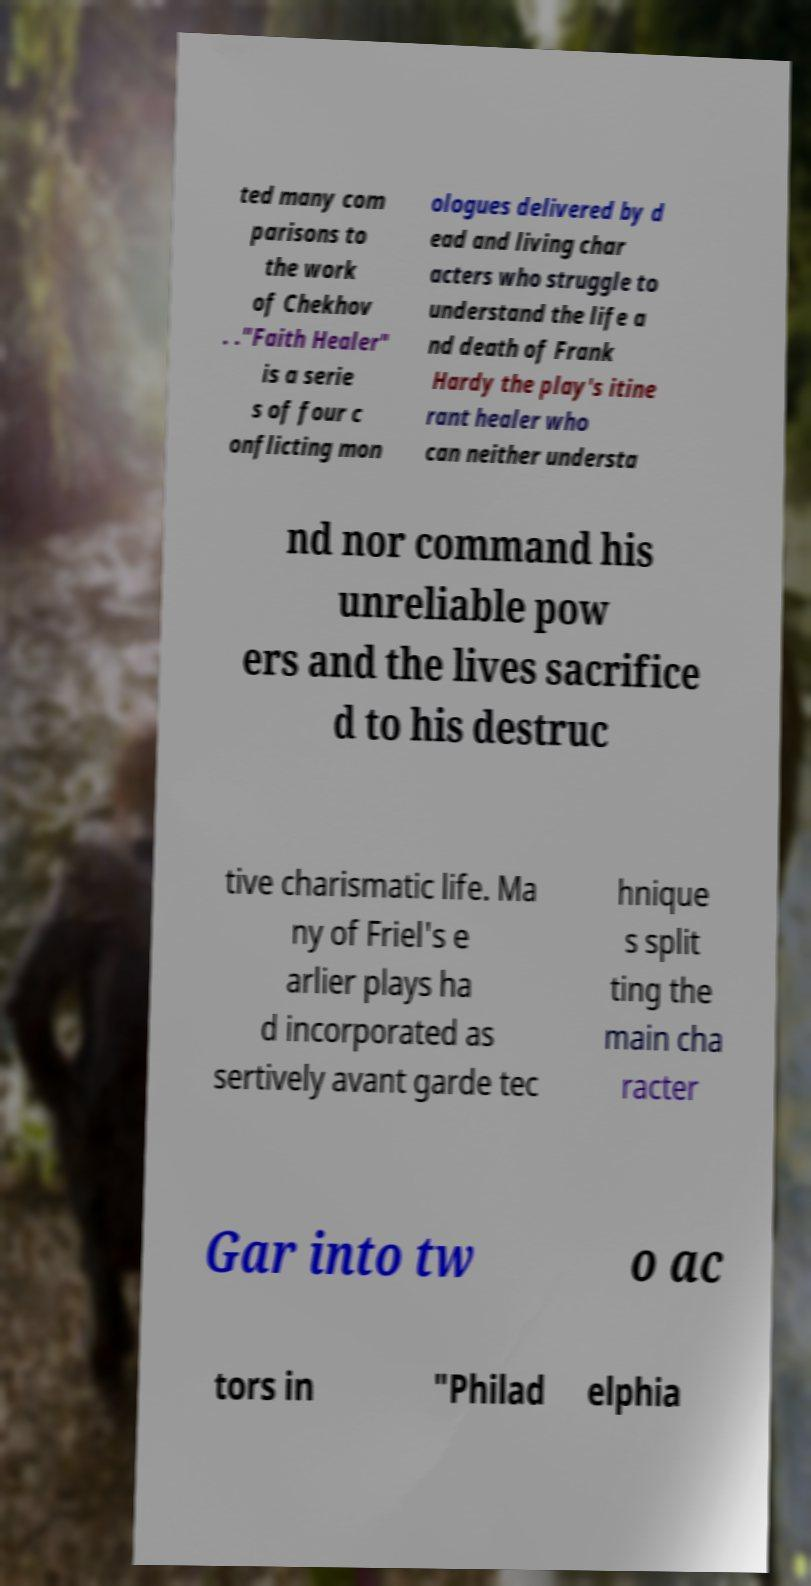I need the written content from this picture converted into text. Can you do that? ted many com parisons to the work of Chekhov . ."Faith Healer" is a serie s of four c onflicting mon ologues delivered by d ead and living char acters who struggle to understand the life a nd death of Frank Hardy the play's itine rant healer who can neither understa nd nor command his unreliable pow ers and the lives sacrifice d to his destruc tive charismatic life. Ma ny of Friel's e arlier plays ha d incorporated as sertively avant garde tec hnique s split ting the main cha racter Gar into tw o ac tors in "Philad elphia 